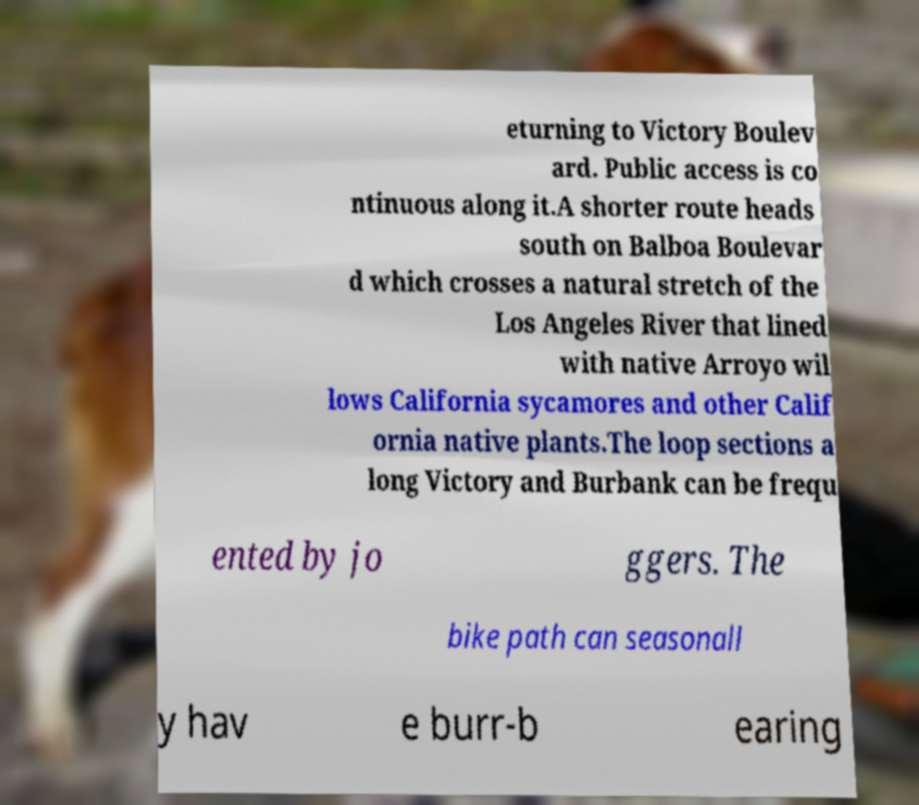Please read and relay the text visible in this image. What does it say? eturning to Victory Boulev ard. Public access is co ntinuous along it.A shorter route heads south on Balboa Boulevar d which crosses a natural stretch of the Los Angeles River that lined with native Arroyo wil lows California sycamores and other Calif ornia native plants.The loop sections a long Victory and Burbank can be frequ ented by jo ggers. The bike path can seasonall y hav e burr-b earing 